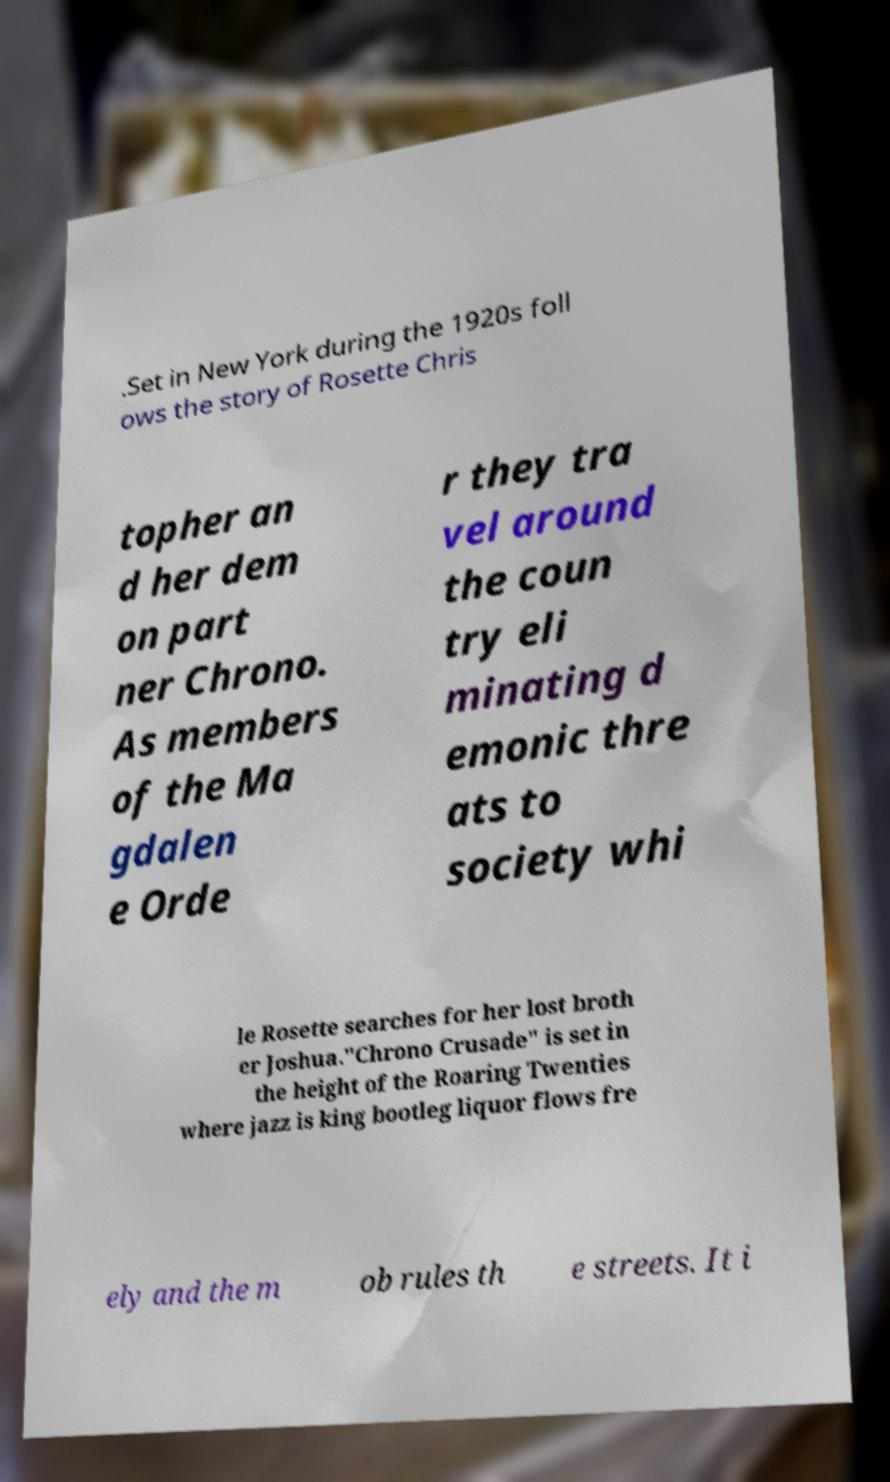Could you extract and type out the text from this image? .Set in New York during the 1920s foll ows the story of Rosette Chris topher an d her dem on part ner Chrono. As members of the Ma gdalen e Orde r they tra vel around the coun try eli minating d emonic thre ats to society whi le Rosette searches for her lost broth er Joshua."Chrono Crusade" is set in the height of the Roaring Twenties where jazz is king bootleg liquor flows fre ely and the m ob rules th e streets. It i 